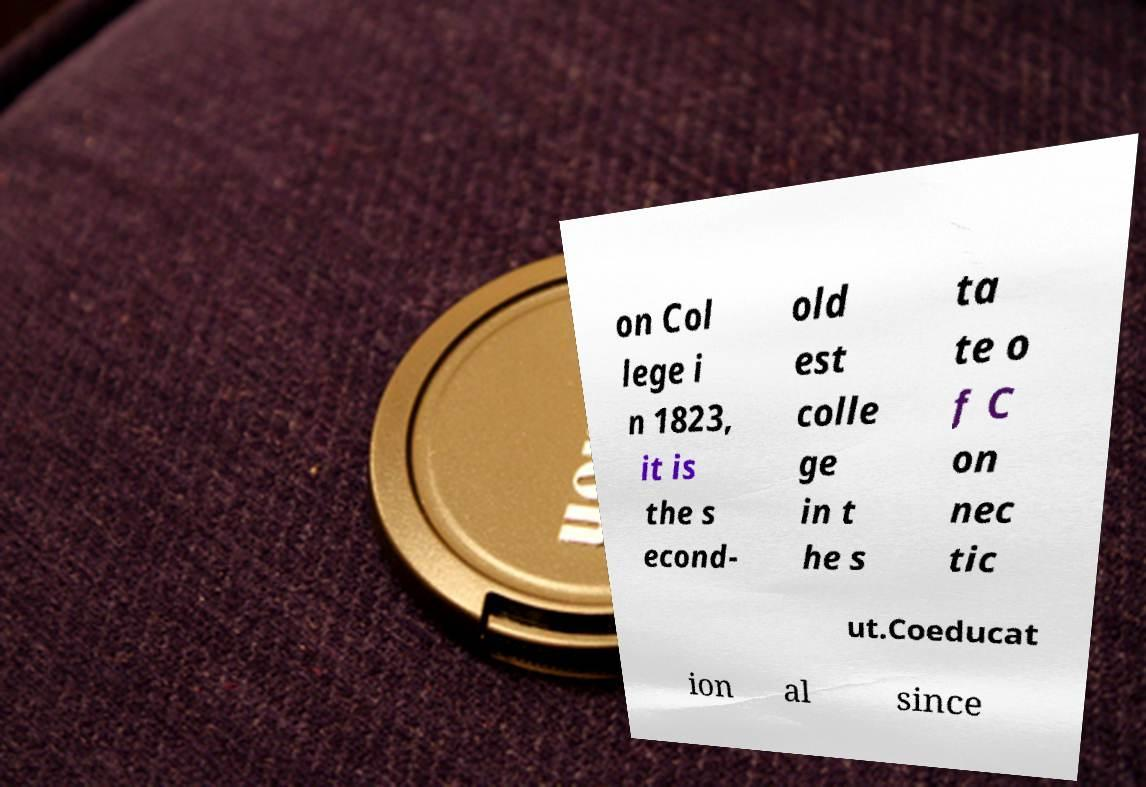Could you assist in decoding the text presented in this image and type it out clearly? on Col lege i n 1823, it is the s econd- old est colle ge in t he s ta te o f C on nec tic ut.Coeducat ion al since 